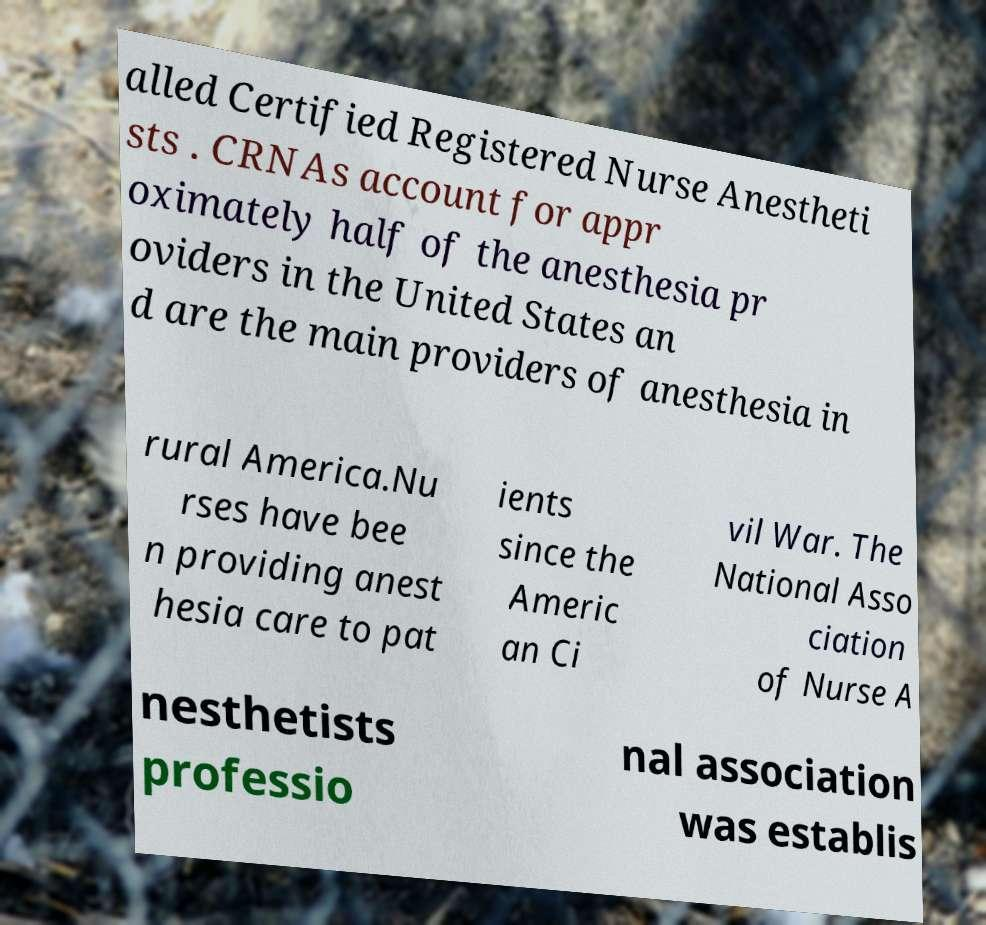Can you read and provide the text displayed in the image?This photo seems to have some interesting text. Can you extract and type it out for me? alled Certified Registered Nurse Anestheti sts . CRNAs account for appr oximately half of the anesthesia pr oviders in the United States an d are the main providers of anesthesia in rural America.Nu rses have bee n providing anest hesia care to pat ients since the Americ an Ci vil War. The National Asso ciation of Nurse A nesthetists professio nal association was establis 